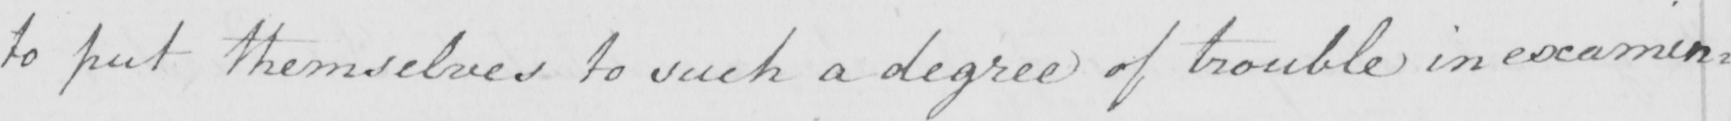Please transcribe the handwritten text in this image. to put themselves to such a degree of trouble in examin= 